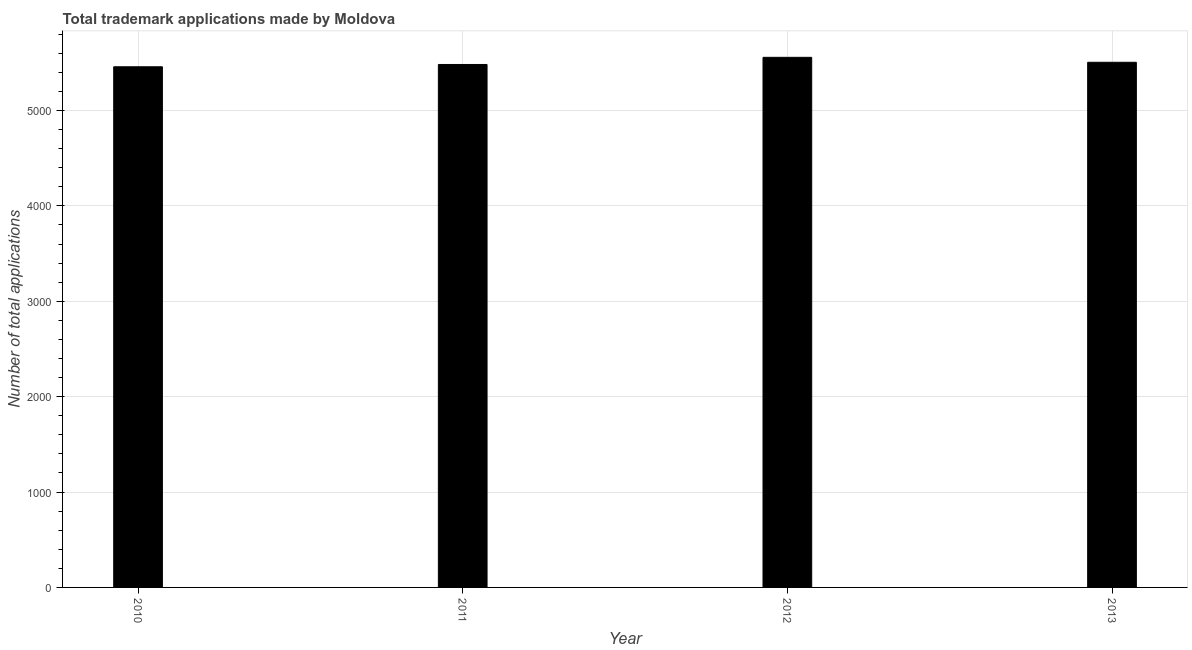Does the graph contain grids?
Offer a terse response. Yes. What is the title of the graph?
Make the answer very short. Total trademark applications made by Moldova. What is the label or title of the Y-axis?
Offer a very short reply. Number of total applications. What is the number of trademark applications in 2013?
Ensure brevity in your answer.  5506. Across all years, what is the maximum number of trademark applications?
Ensure brevity in your answer.  5558. Across all years, what is the minimum number of trademark applications?
Keep it short and to the point. 5459. In which year was the number of trademark applications maximum?
Your response must be concise. 2012. In which year was the number of trademark applications minimum?
Keep it short and to the point. 2010. What is the sum of the number of trademark applications?
Your answer should be very brief. 2.20e+04. What is the average number of trademark applications per year?
Your answer should be compact. 5501. What is the median number of trademark applications?
Provide a succinct answer. 5494.5. In how many years, is the number of trademark applications greater than 1800 ?
Offer a terse response. 4. Do a majority of the years between 2010 and 2013 (inclusive) have number of trademark applications greater than 4800 ?
Ensure brevity in your answer.  Yes. What is the ratio of the number of trademark applications in 2010 to that in 2011?
Ensure brevity in your answer.  1. Is the difference between the number of trademark applications in 2011 and 2013 greater than the difference between any two years?
Offer a terse response. No. What is the difference between the highest and the second highest number of trademark applications?
Offer a terse response. 52. In how many years, is the number of trademark applications greater than the average number of trademark applications taken over all years?
Ensure brevity in your answer.  2. How many years are there in the graph?
Provide a succinct answer. 4. What is the difference between two consecutive major ticks on the Y-axis?
Ensure brevity in your answer.  1000. What is the Number of total applications of 2010?
Give a very brief answer. 5459. What is the Number of total applications of 2011?
Your answer should be compact. 5483. What is the Number of total applications in 2012?
Ensure brevity in your answer.  5558. What is the Number of total applications in 2013?
Make the answer very short. 5506. What is the difference between the Number of total applications in 2010 and 2011?
Keep it short and to the point. -24. What is the difference between the Number of total applications in 2010 and 2012?
Offer a terse response. -99. What is the difference between the Number of total applications in 2010 and 2013?
Your answer should be compact. -47. What is the difference between the Number of total applications in 2011 and 2012?
Offer a very short reply. -75. What is the ratio of the Number of total applications in 2010 to that in 2011?
Offer a very short reply. 1. What is the ratio of the Number of total applications in 2010 to that in 2012?
Make the answer very short. 0.98. 